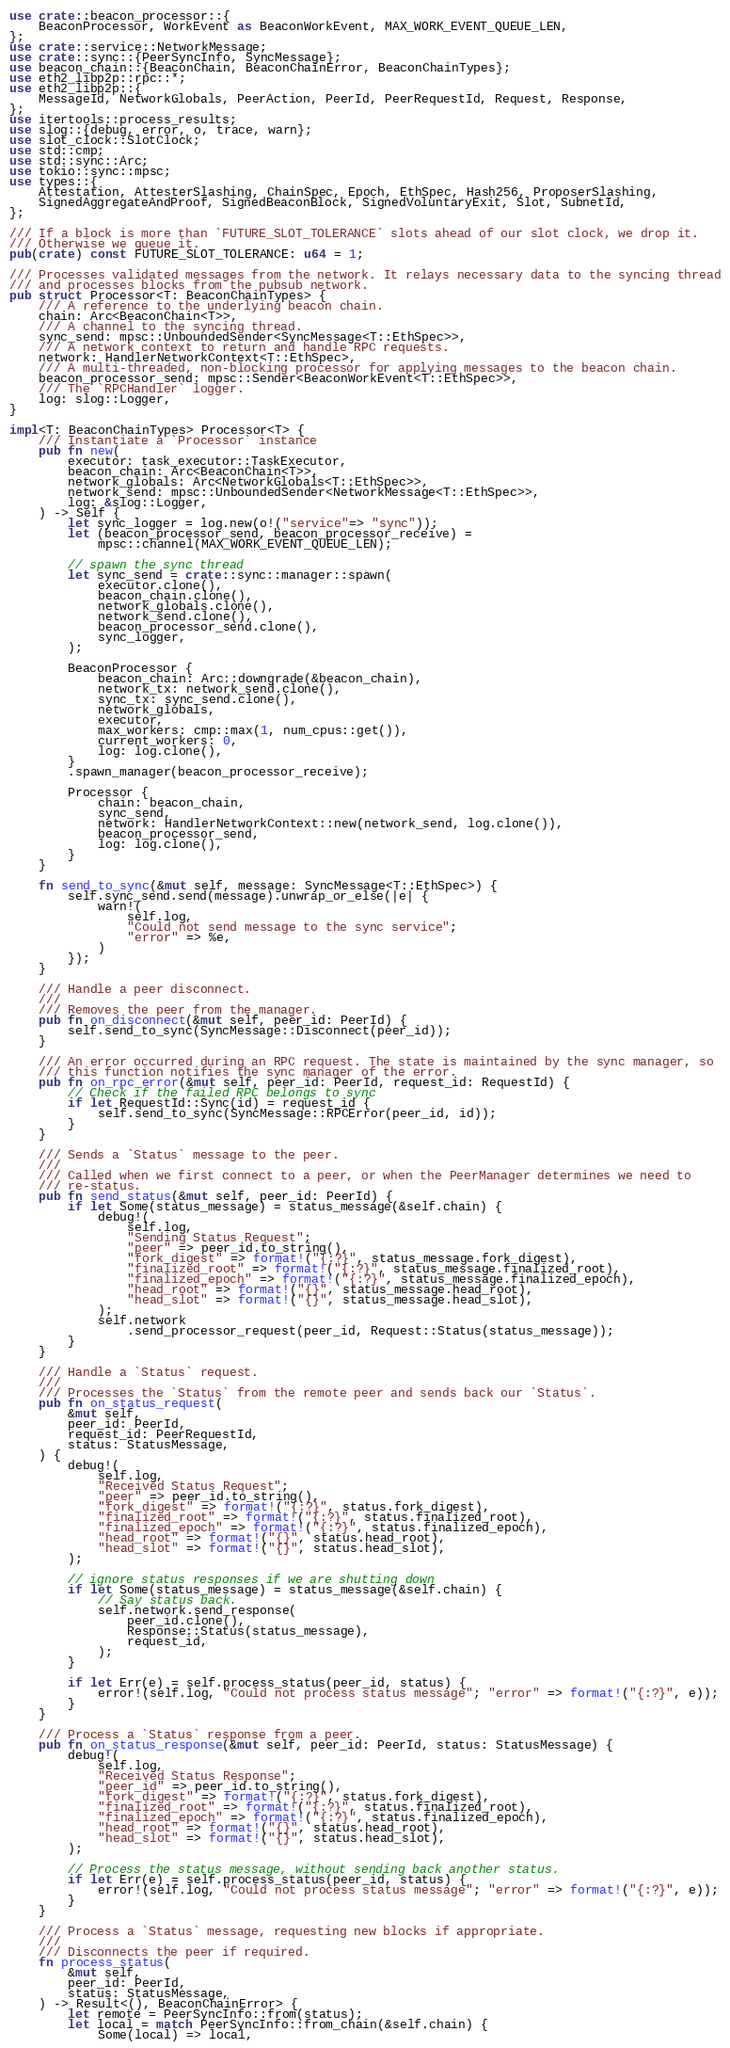<code> <loc_0><loc_0><loc_500><loc_500><_Rust_>use crate::beacon_processor::{
    BeaconProcessor, WorkEvent as BeaconWorkEvent, MAX_WORK_EVENT_QUEUE_LEN,
};
use crate::service::NetworkMessage;
use crate::sync::{PeerSyncInfo, SyncMessage};
use beacon_chain::{BeaconChain, BeaconChainError, BeaconChainTypes};
use eth2_libp2p::rpc::*;
use eth2_libp2p::{
    MessageId, NetworkGlobals, PeerAction, PeerId, PeerRequestId, Request, Response,
};
use itertools::process_results;
use slog::{debug, error, o, trace, warn};
use slot_clock::SlotClock;
use std::cmp;
use std::sync::Arc;
use tokio::sync::mpsc;
use types::{
    Attestation, AttesterSlashing, ChainSpec, Epoch, EthSpec, Hash256, ProposerSlashing,
    SignedAggregateAndProof, SignedBeaconBlock, SignedVoluntaryExit, Slot, SubnetId,
};

/// If a block is more than `FUTURE_SLOT_TOLERANCE` slots ahead of our slot clock, we drop it.
/// Otherwise we queue it.
pub(crate) const FUTURE_SLOT_TOLERANCE: u64 = 1;

/// Processes validated messages from the network. It relays necessary data to the syncing thread
/// and processes blocks from the pubsub network.
pub struct Processor<T: BeaconChainTypes> {
    /// A reference to the underlying beacon chain.
    chain: Arc<BeaconChain<T>>,
    /// A channel to the syncing thread.
    sync_send: mpsc::UnboundedSender<SyncMessage<T::EthSpec>>,
    /// A network context to return and handle RPC requests.
    network: HandlerNetworkContext<T::EthSpec>,
    /// A multi-threaded, non-blocking processor for applying messages to the beacon chain.
    beacon_processor_send: mpsc::Sender<BeaconWorkEvent<T::EthSpec>>,
    /// The `RPCHandler` logger.
    log: slog::Logger,
}

impl<T: BeaconChainTypes> Processor<T> {
    /// Instantiate a `Processor` instance
    pub fn new(
        executor: task_executor::TaskExecutor,
        beacon_chain: Arc<BeaconChain<T>>,
        network_globals: Arc<NetworkGlobals<T::EthSpec>>,
        network_send: mpsc::UnboundedSender<NetworkMessage<T::EthSpec>>,
        log: &slog::Logger,
    ) -> Self {
        let sync_logger = log.new(o!("service"=> "sync"));
        let (beacon_processor_send, beacon_processor_receive) =
            mpsc::channel(MAX_WORK_EVENT_QUEUE_LEN);

        // spawn the sync thread
        let sync_send = crate::sync::manager::spawn(
            executor.clone(),
            beacon_chain.clone(),
            network_globals.clone(),
            network_send.clone(),
            beacon_processor_send.clone(),
            sync_logger,
        );

        BeaconProcessor {
            beacon_chain: Arc::downgrade(&beacon_chain),
            network_tx: network_send.clone(),
            sync_tx: sync_send.clone(),
            network_globals,
            executor,
            max_workers: cmp::max(1, num_cpus::get()),
            current_workers: 0,
            log: log.clone(),
        }
        .spawn_manager(beacon_processor_receive);

        Processor {
            chain: beacon_chain,
            sync_send,
            network: HandlerNetworkContext::new(network_send, log.clone()),
            beacon_processor_send,
            log: log.clone(),
        }
    }

    fn send_to_sync(&mut self, message: SyncMessage<T::EthSpec>) {
        self.sync_send.send(message).unwrap_or_else(|e| {
            warn!(
                self.log,
                "Could not send message to the sync service";
                "error" => %e,
            )
        });
    }

    /// Handle a peer disconnect.
    ///
    /// Removes the peer from the manager.
    pub fn on_disconnect(&mut self, peer_id: PeerId) {
        self.send_to_sync(SyncMessage::Disconnect(peer_id));
    }

    /// An error occurred during an RPC request. The state is maintained by the sync manager, so
    /// this function notifies the sync manager of the error.
    pub fn on_rpc_error(&mut self, peer_id: PeerId, request_id: RequestId) {
        // Check if the failed RPC belongs to sync
        if let RequestId::Sync(id) = request_id {
            self.send_to_sync(SyncMessage::RPCError(peer_id, id));
        }
    }

    /// Sends a `Status` message to the peer.
    ///
    /// Called when we first connect to a peer, or when the PeerManager determines we need to
    /// re-status.
    pub fn send_status(&mut self, peer_id: PeerId) {
        if let Some(status_message) = status_message(&self.chain) {
            debug!(
                self.log,
                "Sending Status Request";
                "peer" => peer_id.to_string(),
                "fork_digest" => format!("{:?}", status_message.fork_digest),
                "finalized_root" => format!("{:?}", status_message.finalized_root),
                "finalized_epoch" => format!("{:?}", status_message.finalized_epoch),
                "head_root" => format!("{}", status_message.head_root),
                "head_slot" => format!("{}", status_message.head_slot),
            );
            self.network
                .send_processor_request(peer_id, Request::Status(status_message));
        }
    }

    /// Handle a `Status` request.
    ///
    /// Processes the `Status` from the remote peer and sends back our `Status`.
    pub fn on_status_request(
        &mut self,
        peer_id: PeerId,
        request_id: PeerRequestId,
        status: StatusMessage,
    ) {
        debug!(
            self.log,
            "Received Status Request";
            "peer" => peer_id.to_string(),
            "fork_digest" => format!("{:?}", status.fork_digest),
            "finalized_root" => format!("{:?}", status.finalized_root),
            "finalized_epoch" => format!("{:?}", status.finalized_epoch),
            "head_root" => format!("{}", status.head_root),
            "head_slot" => format!("{}", status.head_slot),
        );

        // ignore status responses if we are shutting down
        if let Some(status_message) = status_message(&self.chain) {
            // Say status back.
            self.network.send_response(
                peer_id.clone(),
                Response::Status(status_message),
                request_id,
            );
        }

        if let Err(e) = self.process_status(peer_id, status) {
            error!(self.log, "Could not process status message"; "error" => format!("{:?}", e));
        }
    }

    /// Process a `Status` response from a peer.
    pub fn on_status_response(&mut self, peer_id: PeerId, status: StatusMessage) {
        debug!(
            self.log,
            "Received Status Response";
            "peer_id" => peer_id.to_string(),
            "fork_digest" => format!("{:?}", status.fork_digest),
            "finalized_root" => format!("{:?}", status.finalized_root),
            "finalized_epoch" => format!("{:?}", status.finalized_epoch),
            "head_root" => format!("{}", status.head_root),
            "head_slot" => format!("{}", status.head_slot),
        );

        // Process the status message, without sending back another status.
        if let Err(e) = self.process_status(peer_id, status) {
            error!(self.log, "Could not process status message"; "error" => format!("{:?}", e));
        }
    }

    /// Process a `Status` message, requesting new blocks if appropriate.
    ///
    /// Disconnects the peer if required.
    fn process_status(
        &mut self,
        peer_id: PeerId,
        status: StatusMessage,
    ) -> Result<(), BeaconChainError> {
        let remote = PeerSyncInfo::from(status);
        let local = match PeerSyncInfo::from_chain(&self.chain) {
            Some(local) => local,</code> 